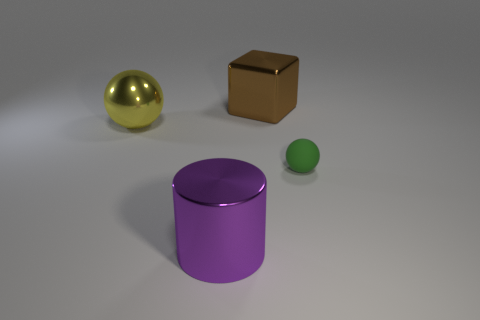Subtract 2 balls. How many balls are left? 0 Add 2 big yellow shiny cylinders. How many objects exist? 6 Subtract all yellow spheres. How many spheres are left? 1 Subtract all cubes. How many objects are left? 3 Subtract 1 yellow balls. How many objects are left? 3 Subtract all cyan blocks. Subtract all yellow cylinders. How many blocks are left? 1 Subtract all blue blocks. How many purple spheres are left? 0 Subtract all large red rubber spheres. Subtract all shiny blocks. How many objects are left? 3 Add 4 metallic objects. How many metallic objects are left? 7 Add 3 shiny things. How many shiny things exist? 6 